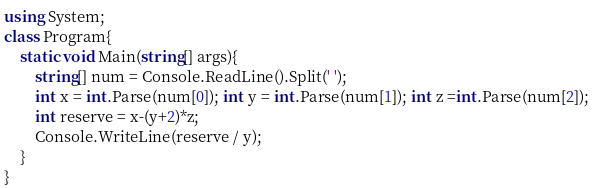<code> <loc_0><loc_0><loc_500><loc_500><_C#_>using System;
class Program{
    static void Main(string[] args){
        string[] num = Console.ReadLine().Split(' ');
        int x = int.Parse(num[0]); int y = int.Parse(num[1]); int z =int.Parse(num[2]);
        int reserve = x-(y+2)*z;
        Console.WriteLine(reserve / y);
    }
}</code> 